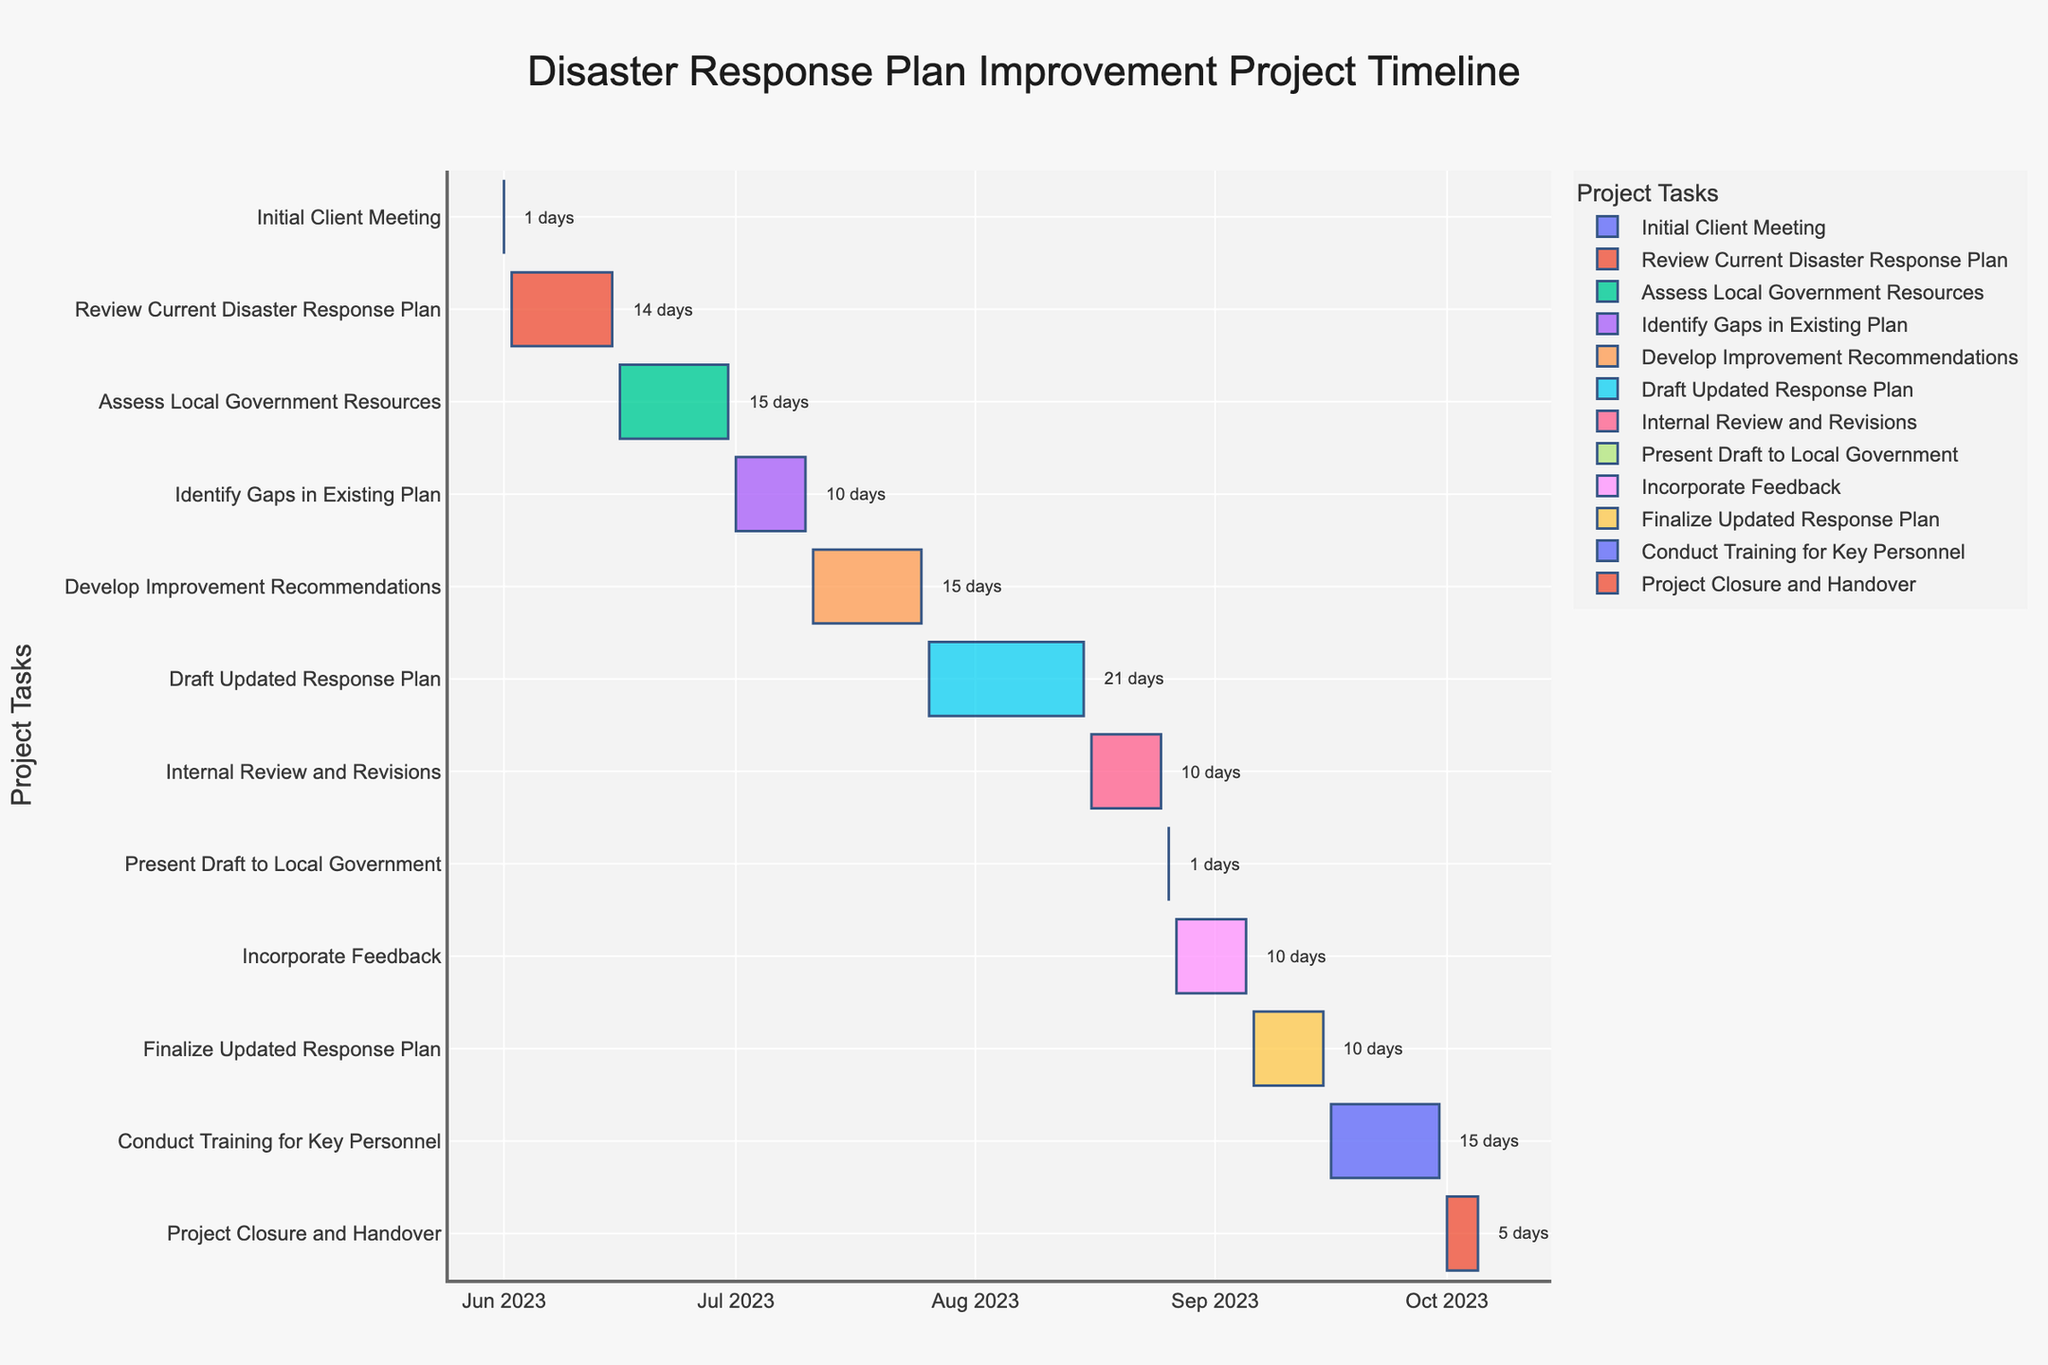What's the title of the Gantt chart? The title is usually at the top of the chart, often centrally aligned.
Answer: "Disaster Response Plan Improvement Project Timeline" How many tasks are included in the project? You can count the number of different bars or rows, each representing a task, listed on the vertical axis.
Answer: 12 Which task has the longest duration? By comparing the horizontal lengths of all bars, the longest one represents the longest duration.
Answer: Draft Updated Response Plan What is the total duration from the start of the project to the end? Identify the start date of the first task and the end date of the last task. Calculate the difference between them. (2023-06-01 to 2023-10-05)
Answer: 127 days Which tasks have the same duration? Identify tasks with equally long horizontal bars by checking the duration annotations or dates.
Answer: Assess Local Government Resources, Develop Improvement Recommendations, Conduct Training for Key Personnel (15 days each) What is the duration of the "Develop Improvement Recommendations" task? Locate the task on the chart and read the annotated duration.
Answer: 15 days How many tasks are scheduled to start in July? Check the start dates listed horizontally and count the number of tasks starting within July 2023.
Answer: 2 Which tasks overlap with "Assess Local Government Resources"? Identify tasks whose bars horizontally intersect with the "Assess Local Government Resources" task bar.
Answer: Identify Gaps in Existing Plan When does the "Conduct Training for Key Personnel" task begin and end? Locate the "Conduct Training for Key Personnel" task and read the start and end dates on the horizontal axis.
Answer: Begins: 2023-09-16, Ends: 2023-09-30 How long after the "Initial Client Meeting" does the "Present Draft to Local Government" occur? Determine the end date of "Initial Client Meeting" and the start date of "Present Draft to Local Government". Calculate the difference between these dates. (2023-06-01 to 2023-08-26)
Answer: 86 days 